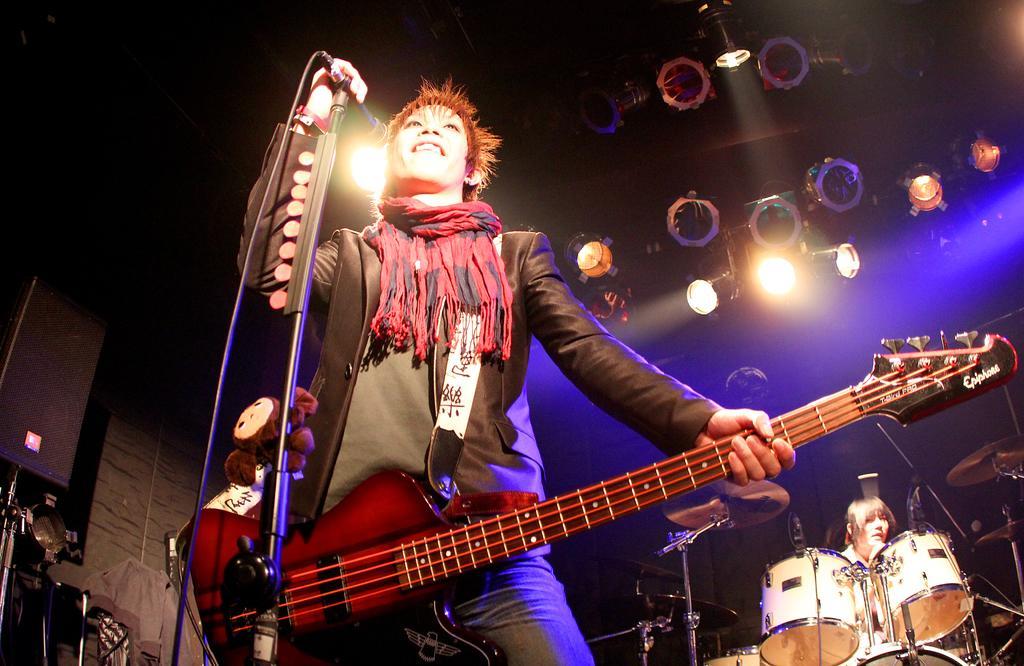Please provide a concise description of this image. a person is standing holding a guitar in one hand and microphone in his other hand. behind him there is another person at the right playing drums. above them there are lights. 